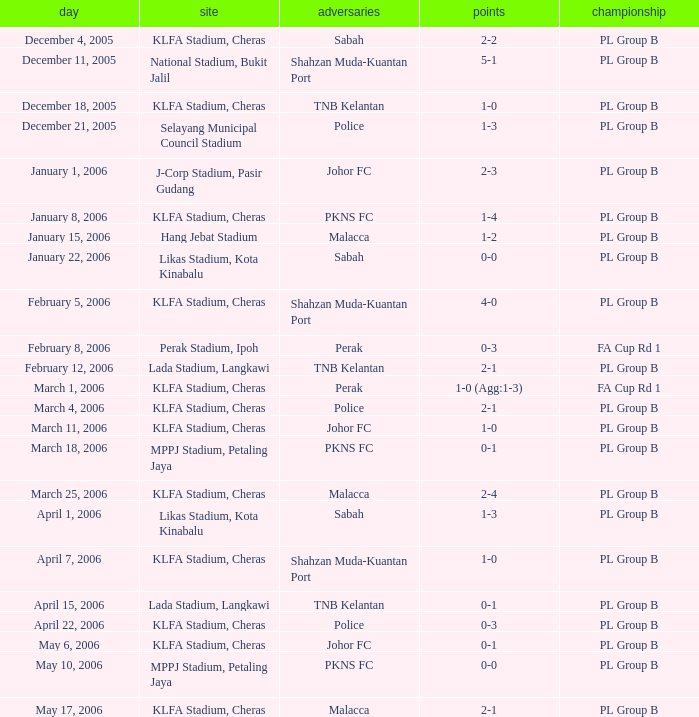Give me the full table as a dictionary. {'header': ['day', 'site', 'adversaries', 'points', 'championship'], 'rows': [['December 4, 2005', 'KLFA Stadium, Cheras', 'Sabah', '2-2', 'PL Group B'], ['December 11, 2005', 'National Stadium, Bukit Jalil', 'Shahzan Muda-Kuantan Port', '5-1', 'PL Group B'], ['December 18, 2005', 'KLFA Stadium, Cheras', 'TNB Kelantan', '1-0', 'PL Group B'], ['December 21, 2005', 'Selayang Municipal Council Stadium', 'Police', '1-3', 'PL Group B'], ['January 1, 2006', 'J-Corp Stadium, Pasir Gudang', 'Johor FC', '2-3', 'PL Group B'], ['January 8, 2006', 'KLFA Stadium, Cheras', 'PKNS FC', '1-4', 'PL Group B'], ['January 15, 2006', 'Hang Jebat Stadium', 'Malacca', '1-2', 'PL Group B'], ['January 22, 2006', 'Likas Stadium, Kota Kinabalu', 'Sabah', '0-0', 'PL Group B'], ['February 5, 2006', 'KLFA Stadium, Cheras', 'Shahzan Muda-Kuantan Port', '4-0', 'PL Group B'], ['February 8, 2006', 'Perak Stadium, Ipoh', 'Perak', '0-3', 'FA Cup Rd 1'], ['February 12, 2006', 'Lada Stadium, Langkawi', 'TNB Kelantan', '2-1', 'PL Group B'], ['March 1, 2006', 'KLFA Stadium, Cheras', 'Perak', '1-0 (Agg:1-3)', 'FA Cup Rd 1'], ['March 4, 2006', 'KLFA Stadium, Cheras', 'Police', '2-1', 'PL Group B'], ['March 11, 2006', 'KLFA Stadium, Cheras', 'Johor FC', '1-0', 'PL Group B'], ['March 18, 2006', 'MPPJ Stadium, Petaling Jaya', 'PKNS FC', '0-1', 'PL Group B'], ['March 25, 2006', 'KLFA Stadium, Cheras', 'Malacca', '2-4', 'PL Group B'], ['April 1, 2006', 'Likas Stadium, Kota Kinabalu', 'Sabah', '1-3', 'PL Group B'], ['April 7, 2006', 'KLFA Stadium, Cheras', 'Shahzan Muda-Kuantan Port', '1-0', 'PL Group B'], ['April 15, 2006', 'Lada Stadium, Langkawi', 'TNB Kelantan', '0-1', 'PL Group B'], ['April 22, 2006', 'KLFA Stadium, Cheras', 'Police', '0-3', 'PL Group B'], ['May 6, 2006', 'KLFA Stadium, Cheras', 'Johor FC', '0-1', 'PL Group B'], ['May 10, 2006', 'MPPJ Stadium, Petaling Jaya', 'PKNS FC', '0-0', 'PL Group B'], ['May 17, 2006', 'KLFA Stadium, Cheras', 'Malacca', '2-1', 'PL Group B']]} Which Venue has a Competition of pl group b, and a Score of 2-2? KLFA Stadium, Cheras. 